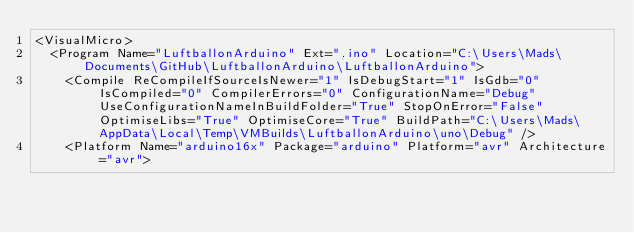Convert code to text. <code><loc_0><loc_0><loc_500><loc_500><_XML_><VisualMicro>
  <Program Name="LuftballonArduino" Ext=".ino" Location="C:\Users\Mads\Documents\GitHub\LuftballonArduino\LuftballonArduino">
    <Compile ReCompileIfSourceIsNewer="1" IsDebugStart="1" IsGdb="0" IsCompiled="0" CompilerErrors="0" ConfigurationName="Debug" UseConfigurationNameInBuildFolder="True" StopOnError="False" OptimiseLibs="True" OptimiseCore="True" BuildPath="C:\Users\Mads\AppData\Local\Temp\VMBuilds\LuftballonArduino\uno\Debug" />
    <Platform Name="arduino16x" Package="arduino" Platform="avr" Architecture="avr"></code> 